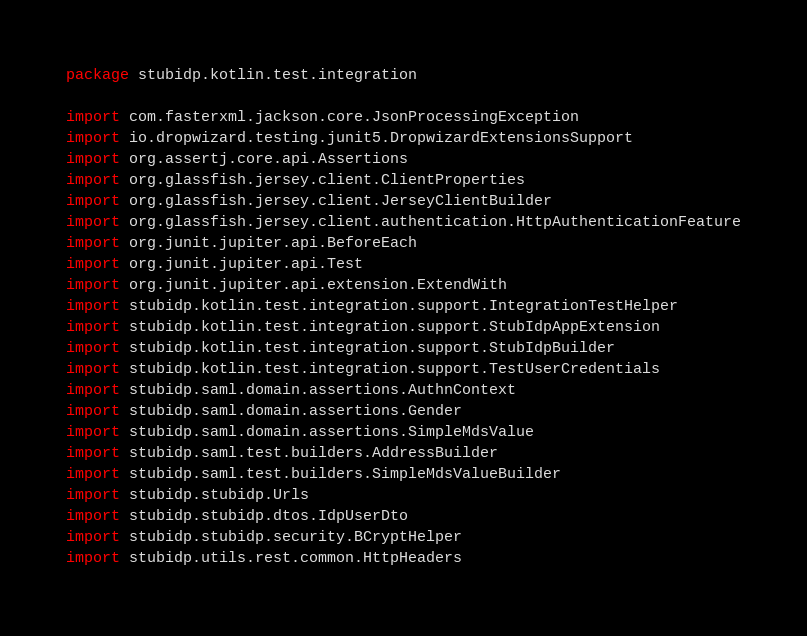Convert code to text. <code><loc_0><loc_0><loc_500><loc_500><_Kotlin_>package stubidp.kotlin.test.integration

import com.fasterxml.jackson.core.JsonProcessingException
import io.dropwizard.testing.junit5.DropwizardExtensionsSupport
import org.assertj.core.api.Assertions
import org.glassfish.jersey.client.ClientProperties
import org.glassfish.jersey.client.JerseyClientBuilder
import org.glassfish.jersey.client.authentication.HttpAuthenticationFeature
import org.junit.jupiter.api.BeforeEach
import org.junit.jupiter.api.Test
import org.junit.jupiter.api.extension.ExtendWith
import stubidp.kotlin.test.integration.support.IntegrationTestHelper
import stubidp.kotlin.test.integration.support.StubIdpAppExtension
import stubidp.kotlin.test.integration.support.StubIdpBuilder
import stubidp.kotlin.test.integration.support.TestUserCredentials
import stubidp.saml.domain.assertions.AuthnContext
import stubidp.saml.domain.assertions.Gender
import stubidp.saml.domain.assertions.SimpleMdsValue
import stubidp.saml.test.builders.AddressBuilder
import stubidp.saml.test.builders.SimpleMdsValueBuilder
import stubidp.stubidp.Urls
import stubidp.stubidp.dtos.IdpUserDto
import stubidp.stubidp.security.BCryptHelper
import stubidp.utils.rest.common.HttpHeaders</code> 